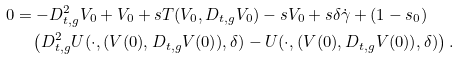<formula> <loc_0><loc_0><loc_500><loc_500>0 & = - D _ { t , g } ^ { 2 } V _ { 0 } + V _ { 0 } + s T ( V _ { 0 } , D _ { t , g } V _ { 0 } ) - s V _ { 0 } + s \delta \dot { \gamma } + ( 1 - s _ { 0 } ) \\ & \quad \left ( D _ { t , g } ^ { 2 } U ( \cdot , ( V ( 0 ) , D _ { t , g } V ( 0 ) ) , \delta ) - U ( \cdot , ( V ( 0 ) , D _ { t , g } V ( 0 ) ) , \delta ) \right ) .</formula> 